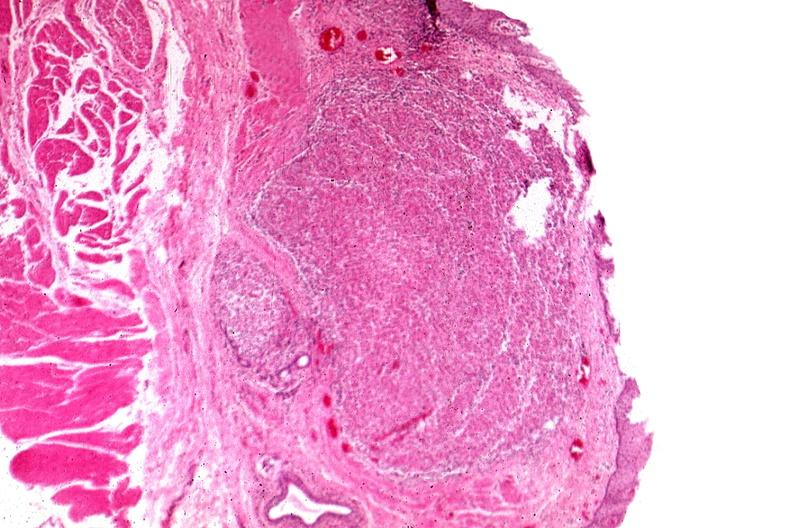does this image show tunica propria granulomas?
Answer the question using a single word or phrase. Yes 